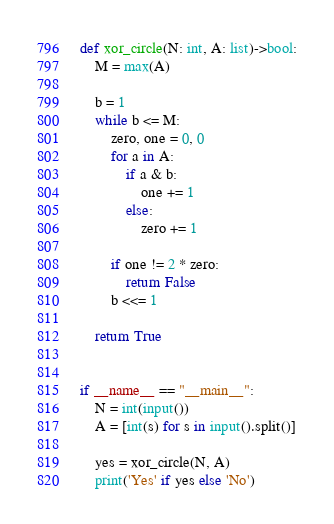Convert code to text. <code><loc_0><loc_0><loc_500><loc_500><_Python_>def xor_circle(N: int, A: list)->bool:
    M = max(A)

    b = 1
    while b <= M:
        zero, one = 0, 0
        for a in A:
            if a & b:
                one += 1
            else:
                zero += 1

        if one != 2 * zero:
            return False
        b <<= 1

    return True


if __name__ == "__main__":
    N = int(input())
    A = [int(s) for s in input().split()]

    yes = xor_circle(N, A)
    print('Yes' if yes else 'No')
</code> 